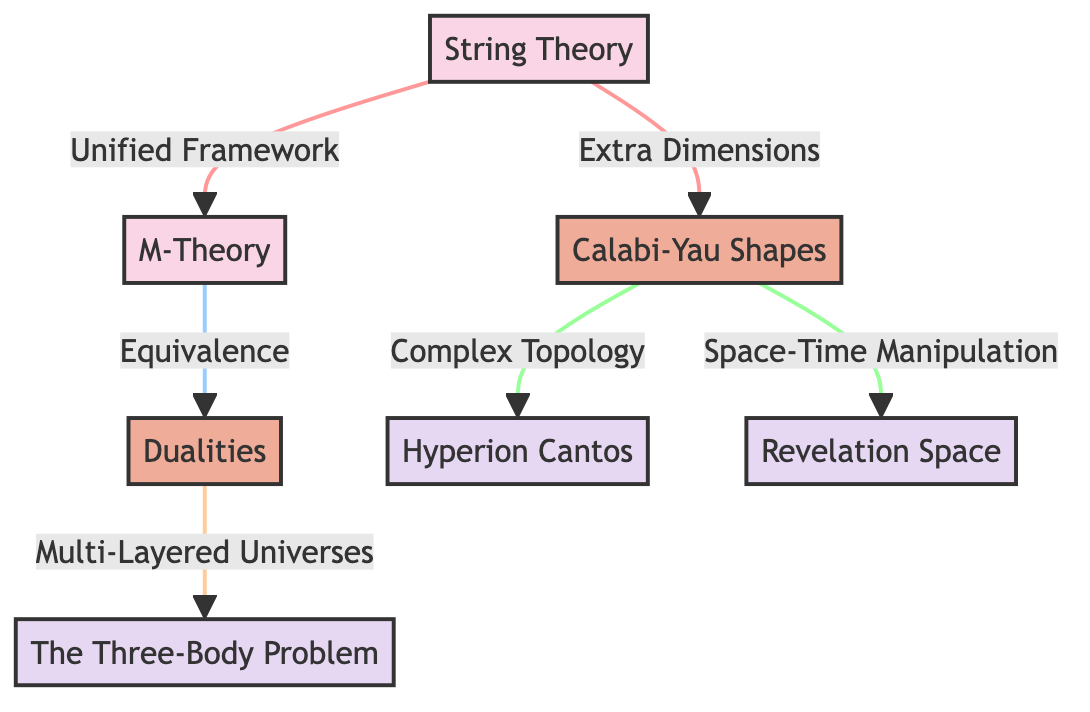What is the first node in the diagram? The first node is labeled "String Theory," representing the foundational concept being discussed.
Answer: String Theory How many fictional works are referenced in the diagram? There are three fictional works referenced in the diagram, shown as nodes connected to different concepts.
Answer: 3 What concept is connected to "Calabi-Yau Shapes"? "Calabi-Yau Shapes" is directly connected to two concepts: "Complex Topology" and "Space-Time Manipulation."
Answer: Complex Topology, Space-Time Manipulation Which theory is derived from "String Theory" that relates to multiple dimensions? The theory derived from "String Theory" that relates to multiple dimensions is "M-Theory."
Answer: M-Theory What is the relationship between "M-Theory" and "Dualities"? "M-Theory" is connected to "Dualities" through an equivalence relationship, indicating that they are interrelated concepts within string theory.
Answer: Equivalence Which fictional work corresponds to the concept of "Multi-Layered Universes"? The fictional work that corresponds to "Multi-Layered Universes" is "The Three-Body Problem," illustrating how this concept is depicted in science fiction.
Answer: The Three-Body Problem How many connections does "Calabi-Yau Shapes" have to fictional worlds? "Calabi-Yau Shapes" has two connections to fictional worlds, demonstrating its influence on different narratives within science fiction.
Answer: 2 What is the main implication derived from "String Theory"? The main implication derived from "String Theory" is a "Unified Framework," highlighting its role as a comprehensive model in theoretical physics.
Answer: Unified Framework Which concept involves space-time manipulation? The concept that involves space-time manipulation is "Calabi-Yau Shapes," indicating its significance in theoretical frameworks addressing such phenomena.
Answer: Space-Time Manipulation 